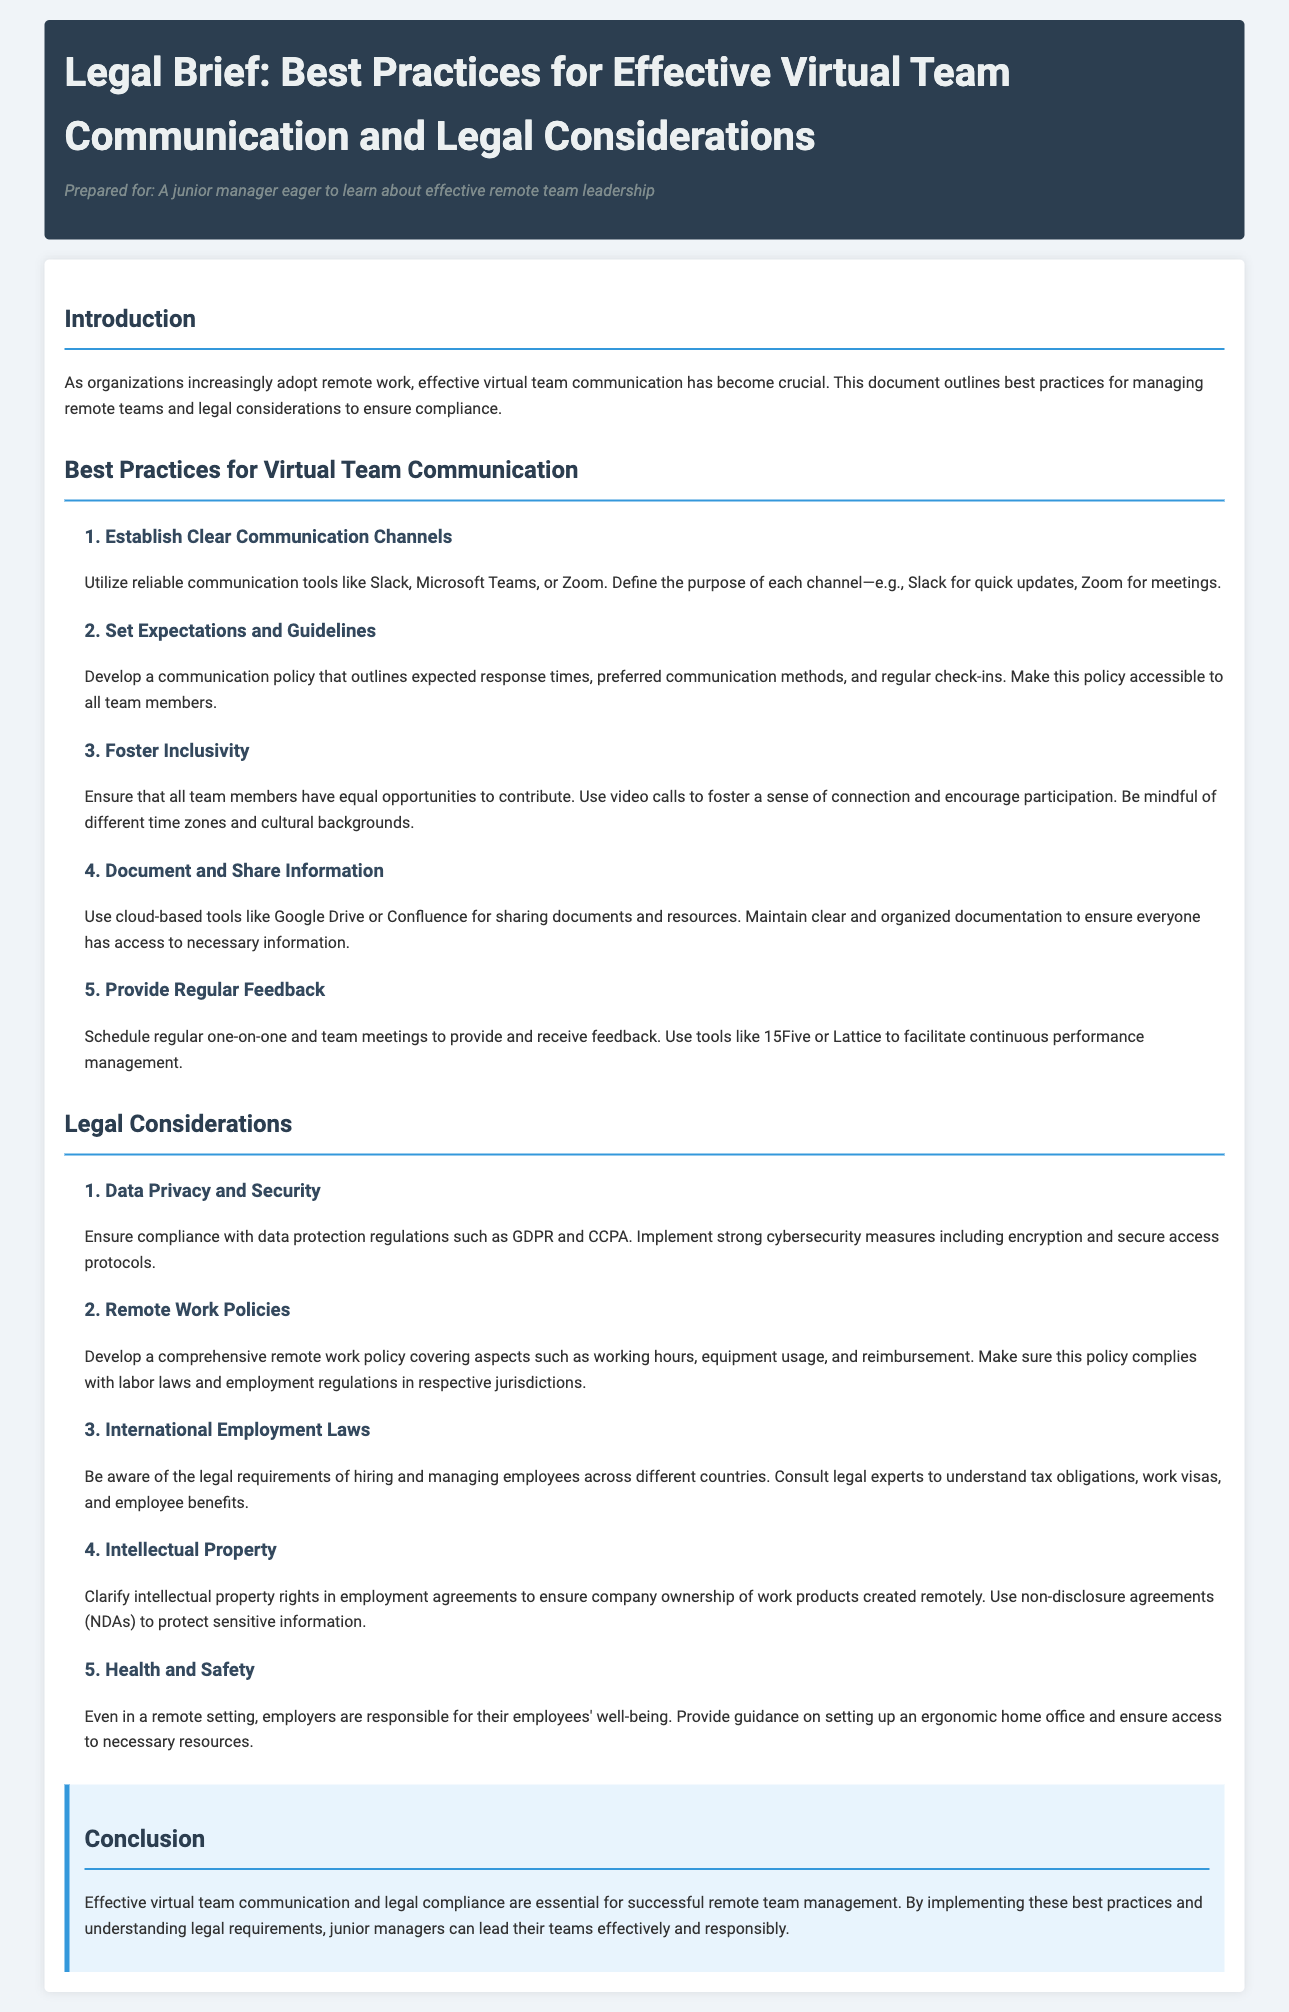What are the best practices for virtual team communication? The document outlines five best practices for effective virtual team communication.
Answer: Five What is the purpose of a communication policy? The communication policy outlines expected response times, preferred communication methods, and regular check-ins.
Answer: Outline expectations What is essential for data privacy and security? Compliance with data protection regulations such as GDPR and CCPA is essential for data privacy and security.
Answer: Compliance What does the document suggest about inclusivity? The document advises ensuring that all team members have equal opportunities to contribute and encourages participation.
Answer: Equal opportunities What should be clarified in employment agreements? Intellectual property rights should be clarified in employment agreements to ensure company ownership.
Answer: Intellectual property rights What measure is suggested for regular feedback? The document suggests scheduling regular one-on-one and team meetings to facilitate feedback.
Answer: Regular meetings What does the conclusion emphasize? The conclusion emphasizes the importance of effective virtual team communication and legal compliance for successful remote management.
Answer: Legal compliance What type of agreements are recommended to protect sensitive information? Non-disclosure agreements (NDAs) are recommended to protect sensitive information.
Answer: Non-disclosure agreements What is a key component of remote work policies? A comprehensive remote work policy should cover aspects such as working hours and equipment usage.
Answer: Comprehensive policy 